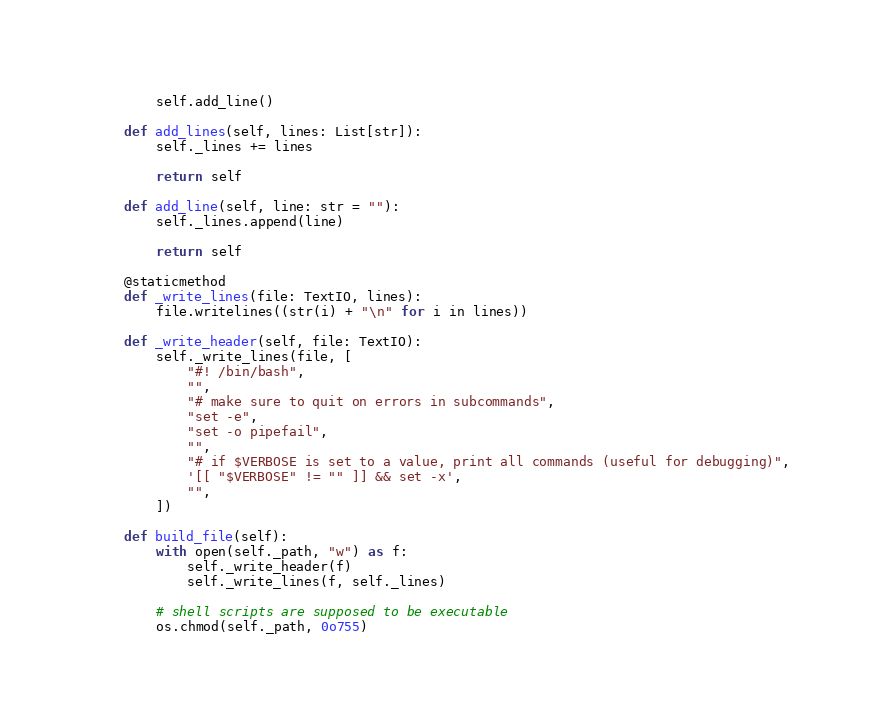Convert code to text. <code><loc_0><loc_0><loc_500><loc_500><_Python_>        self.add_line()

    def add_lines(self, lines: List[str]):
        self._lines += lines

        return self

    def add_line(self, line: str = ""):
        self._lines.append(line)

        return self

    @staticmethod
    def _write_lines(file: TextIO, lines):
        file.writelines((str(i) + "\n" for i in lines))

    def _write_header(self, file: TextIO):
        self._write_lines(file, [
            "#! /bin/bash",
            "",
            "# make sure to quit on errors in subcommands",
            "set -e",
            "set -o pipefail",
            "",
            "# if $VERBOSE is set to a value, print all commands (useful for debugging)",
            '[[ "$VERBOSE" != "" ]] && set -x',
            "",
        ])

    def build_file(self):
        with open(self._path, "w") as f:
            self._write_header(f)
            self._write_lines(f, self._lines)

        # shell scripts are supposed to be executable
        os.chmod(self._path, 0o755)
</code> 